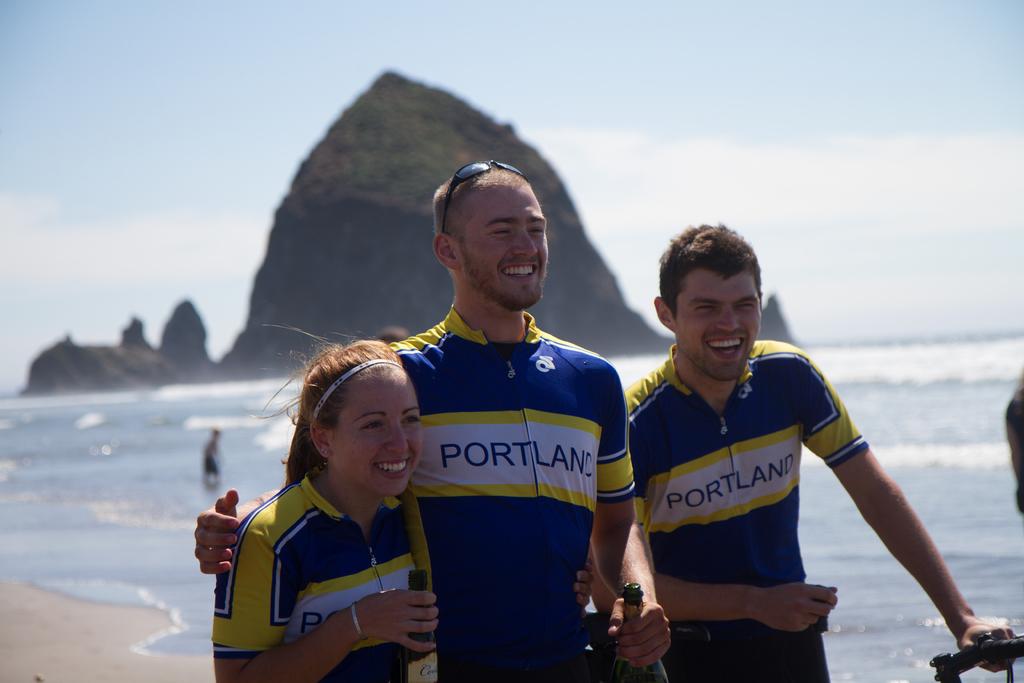What is the name of the city?
Make the answer very short. Portland. 